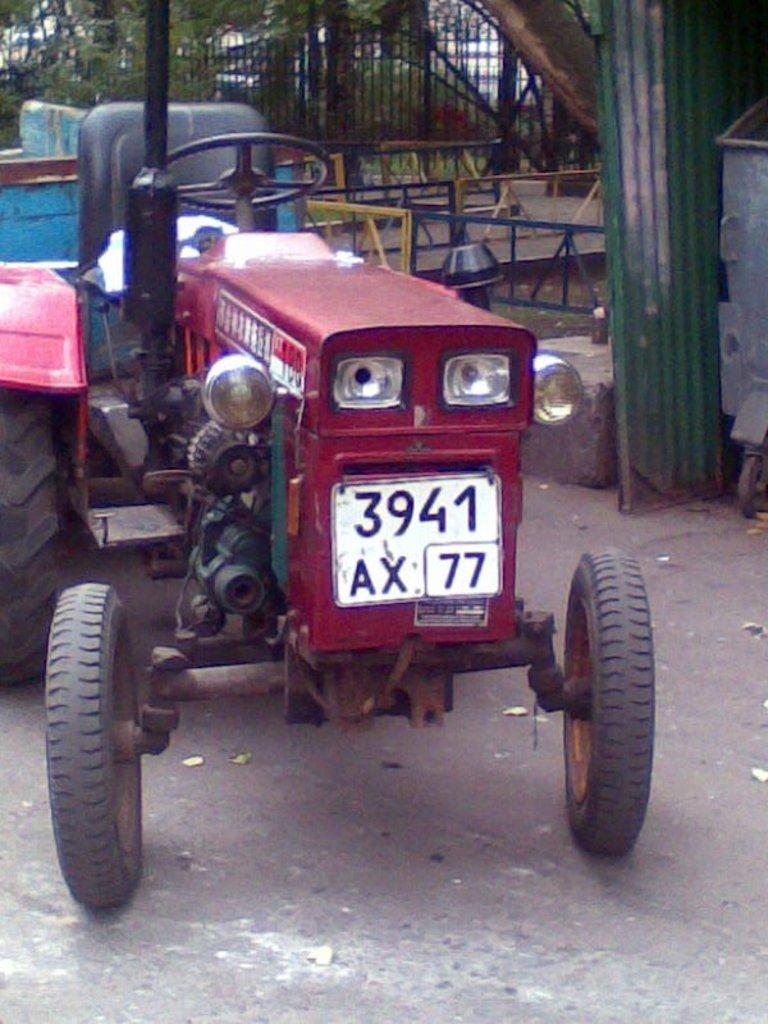What is the main subject of the image? The main subject of the image is a tractor. Where is the tractor located in the image? The tractor is on the ground in the image. What is attached to the back of the tractor? There is a trolley attached to the back of the tractor. What type of barrier can be seen in the image? There is a fence visible in the image. What part of a tree is present in the image? The bark of a tree is present in the image. How many trees can be seen in the image? There are trees in the image. What type of sticks are being used to brush the teeth of the tractor in the image? There are no sticks or teeth present in the image, and the tractor is not an entity that requires brushing of teeth. 